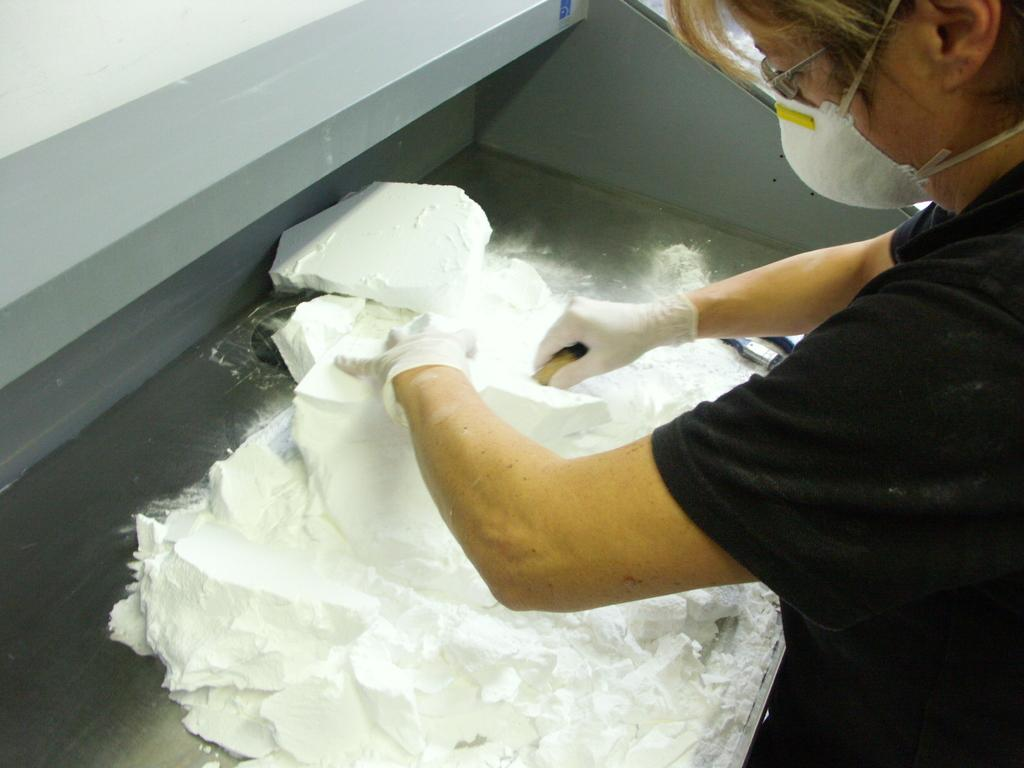What is the main subject of the image? There is a person in the image. What is the person wearing on their hands? The person is wearing gloves. What is the person wearing on their face? The person is wearing a mask. What is the person holding in the image? The person is holding blocks of white colored powder. Where are the blocks of white colored powder placed? The blocks of white colored powder are on a metal platform. What note is the person playing on a musical instrument in the image? There is no musical instrument present in the image, so it is not possible to determine what note might be played. 